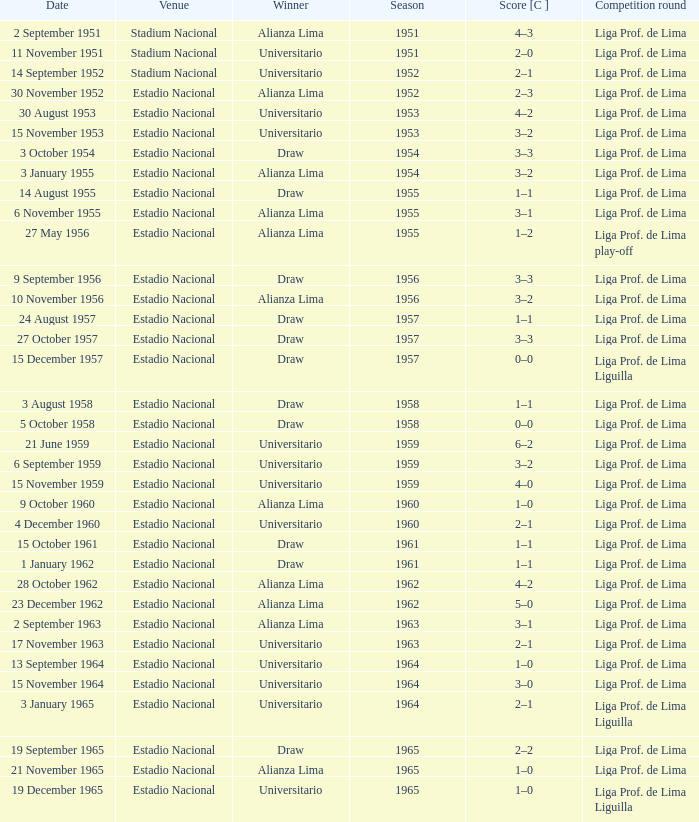What is the score of the event that Alianza Lima won in 1965? 1–0. 